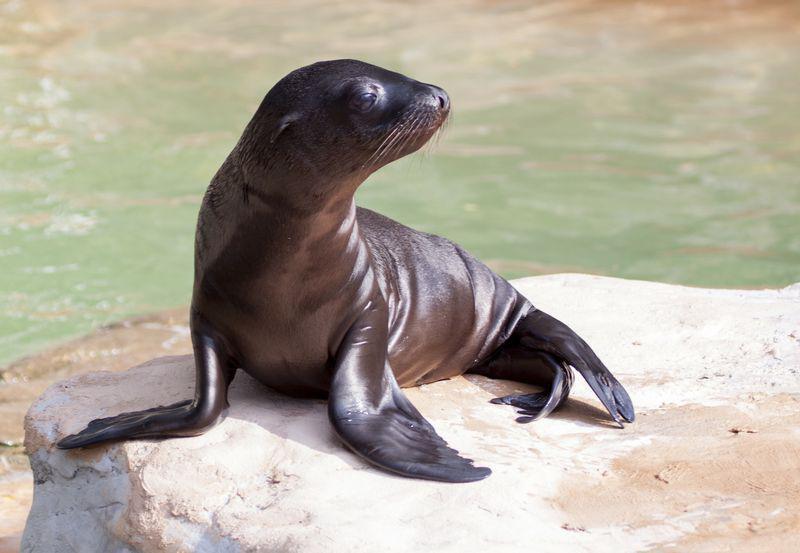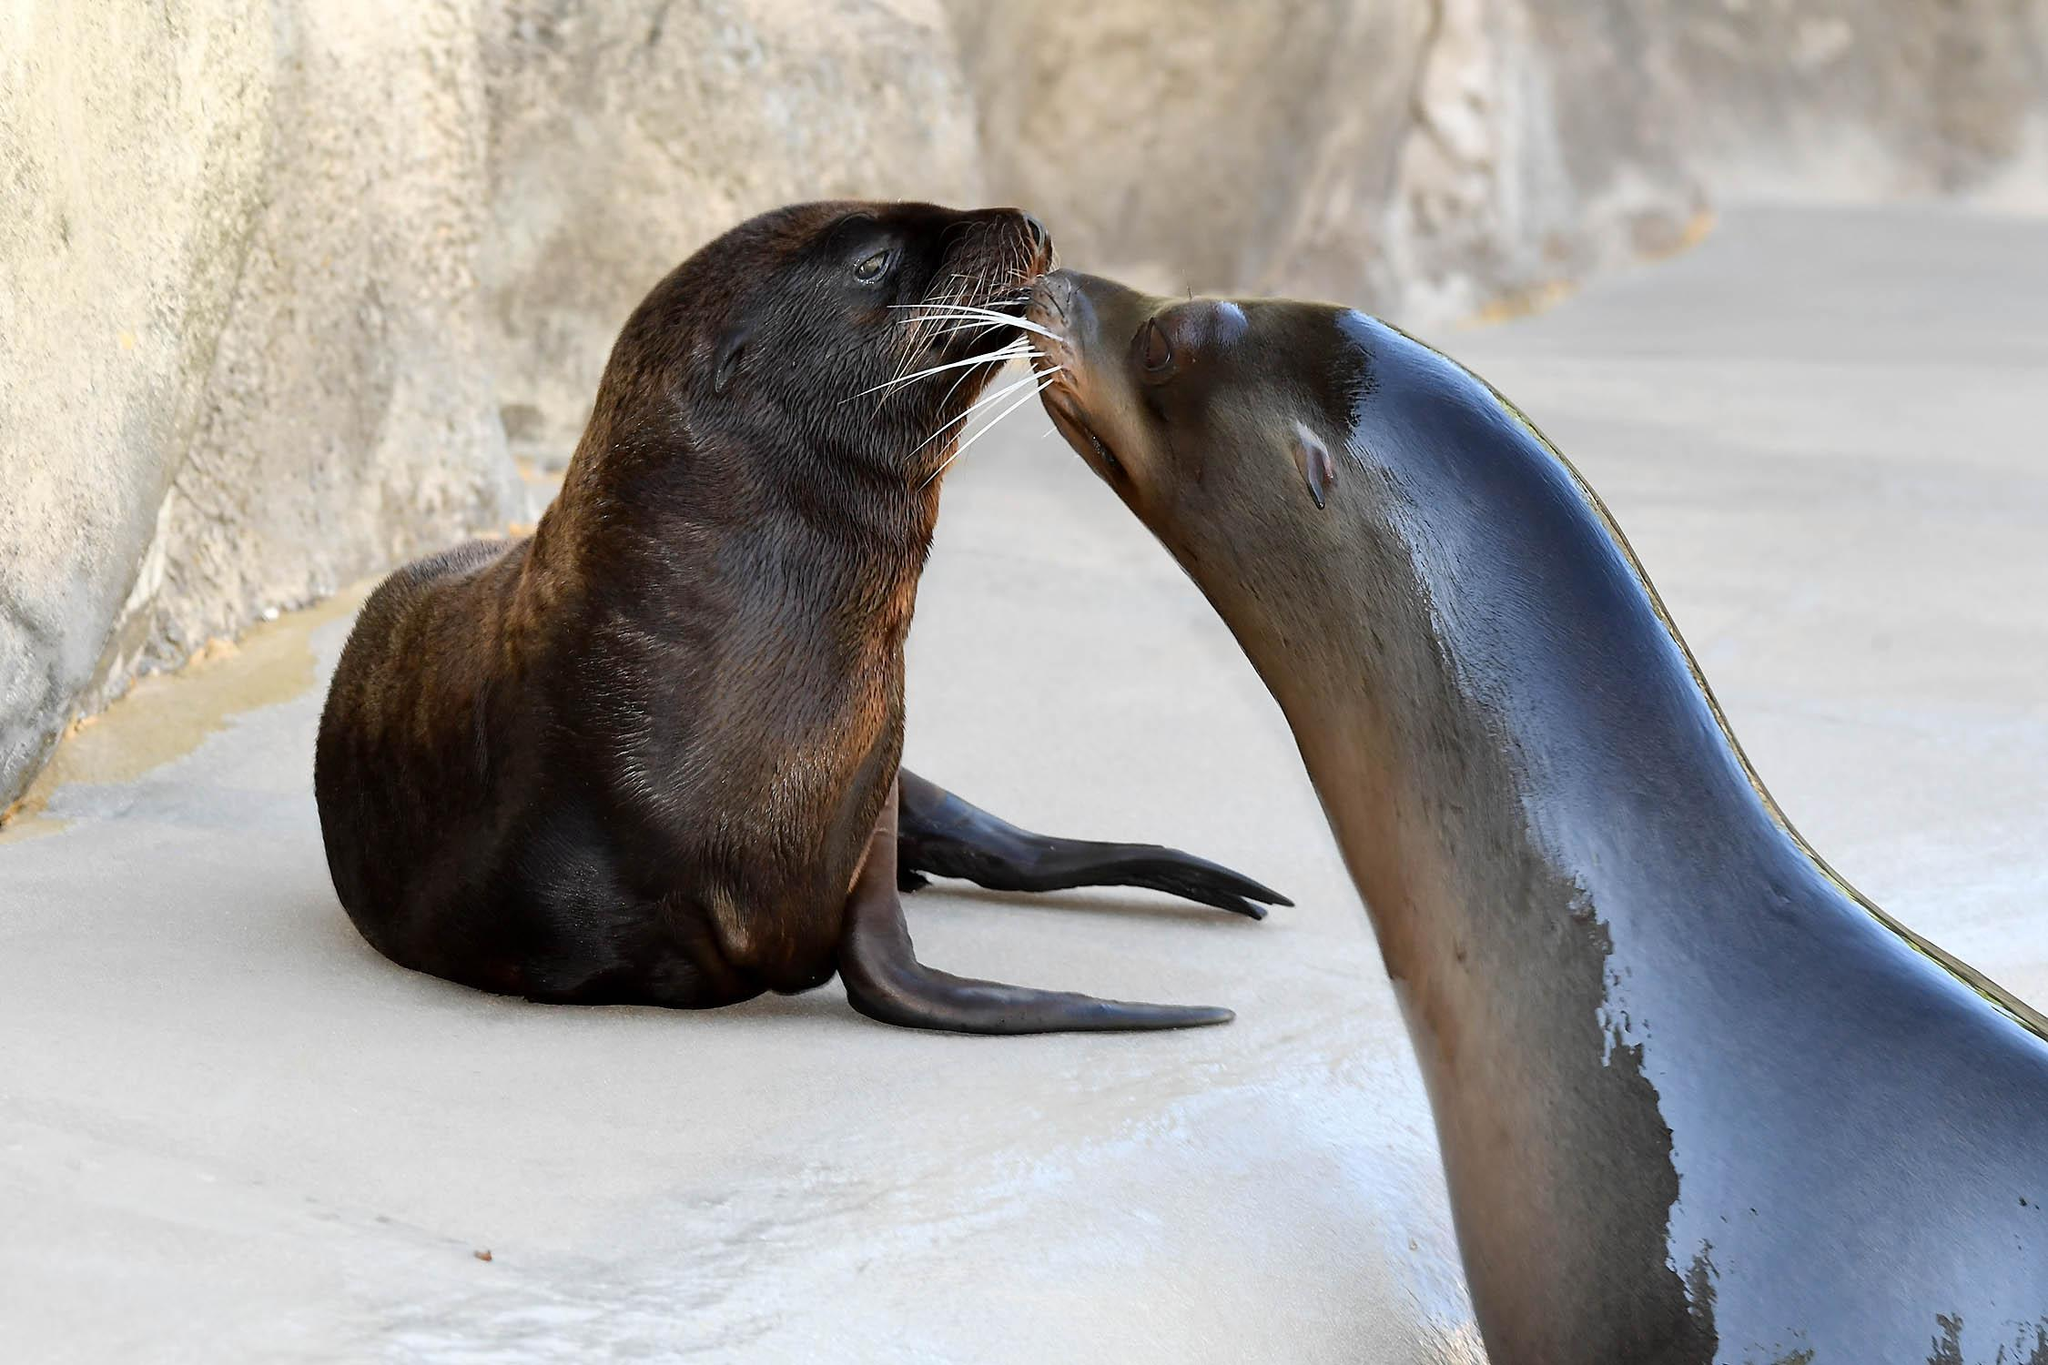The first image is the image on the left, the second image is the image on the right. Analyze the images presented: Is the assertion "The left and right images have the same amount of seals visible." valid? Answer yes or no. No. The first image is the image on the left, the second image is the image on the right. Examine the images to the left and right. Is the description "An adult seal to the right of a baby seal extends its neck to touch noses with the smaller animal." accurate? Answer yes or no. Yes. 